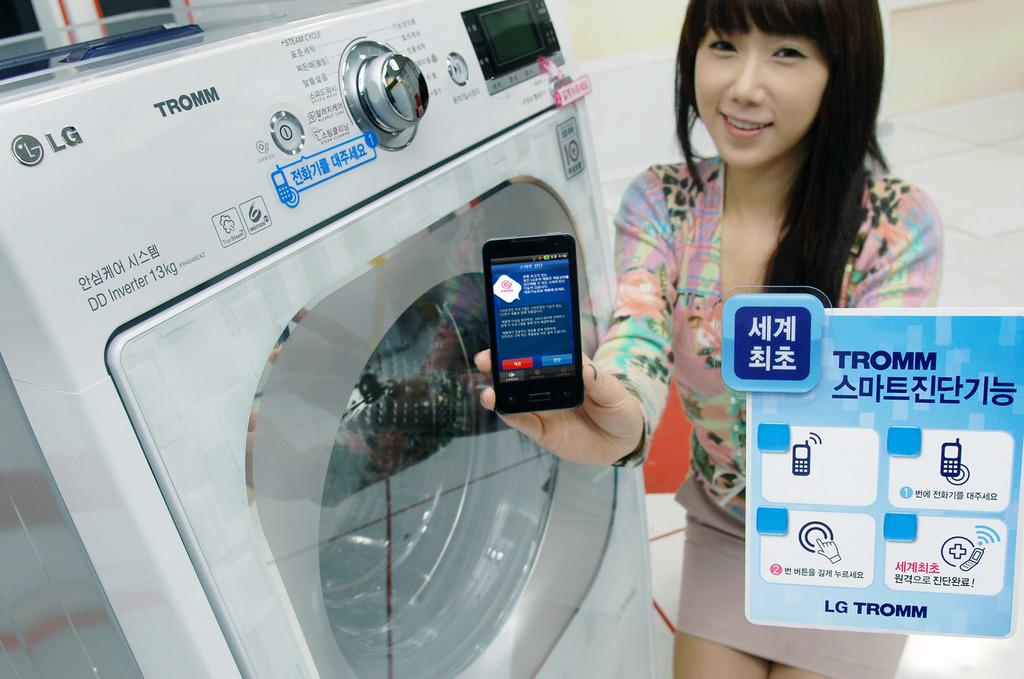Provide a one-sentence caption for the provided image. A woman holds a Tromm mobile device near a washing machine. 